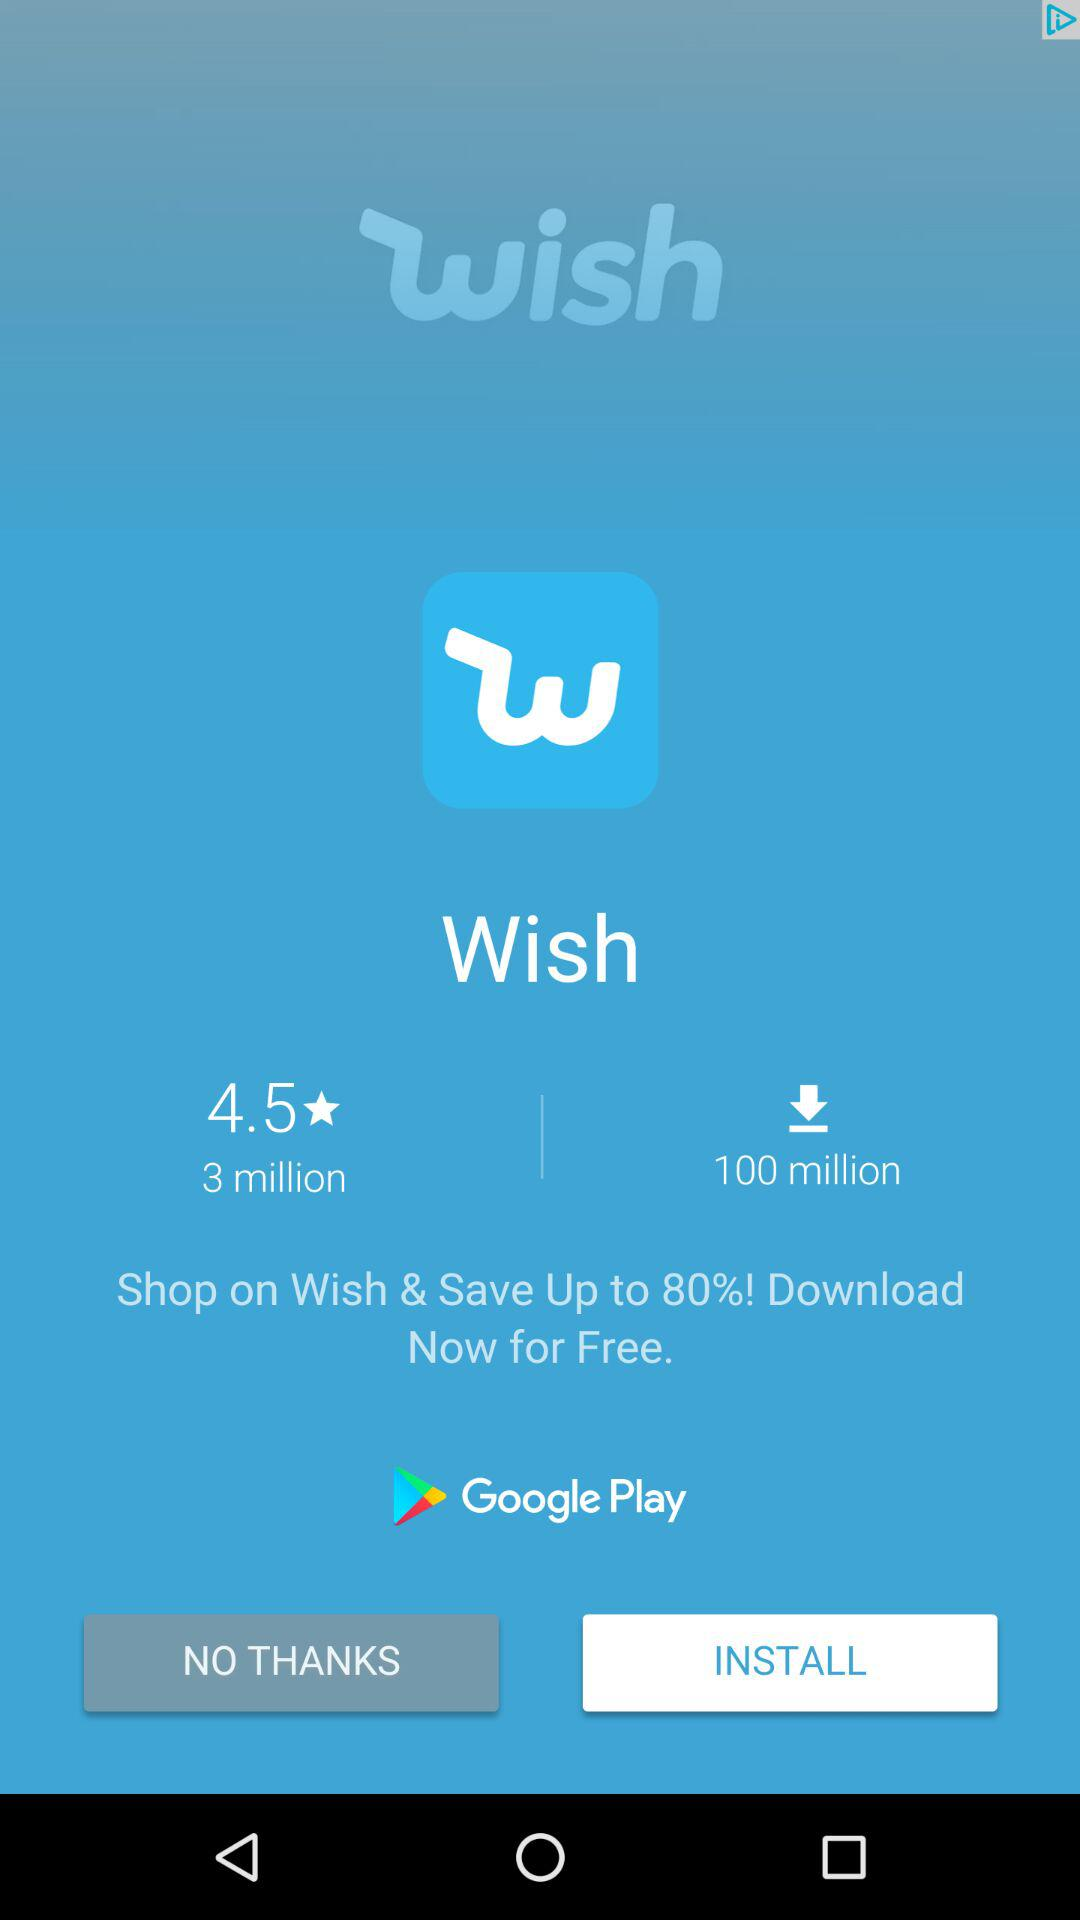How many more downloads does the app have than reviews?
Answer the question using a single word or phrase. 97 million 